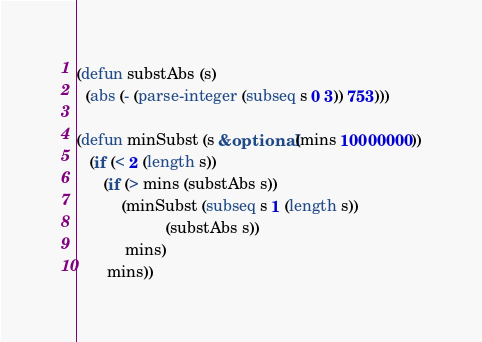Convert code to text. <code><loc_0><loc_0><loc_500><loc_500><_Lisp_>(defun substAbs (s)
  (abs (- (parse-integer (subseq s 0 3)) 753)))

(defun minSubst (s &optional (mins 10000000))
   (if (< 2 (length s))
      (if (> mins (substAbs s))
          (minSubst (subseq s 1 (length s))
                    (substAbs s))
           mins)
       mins))
</code> 